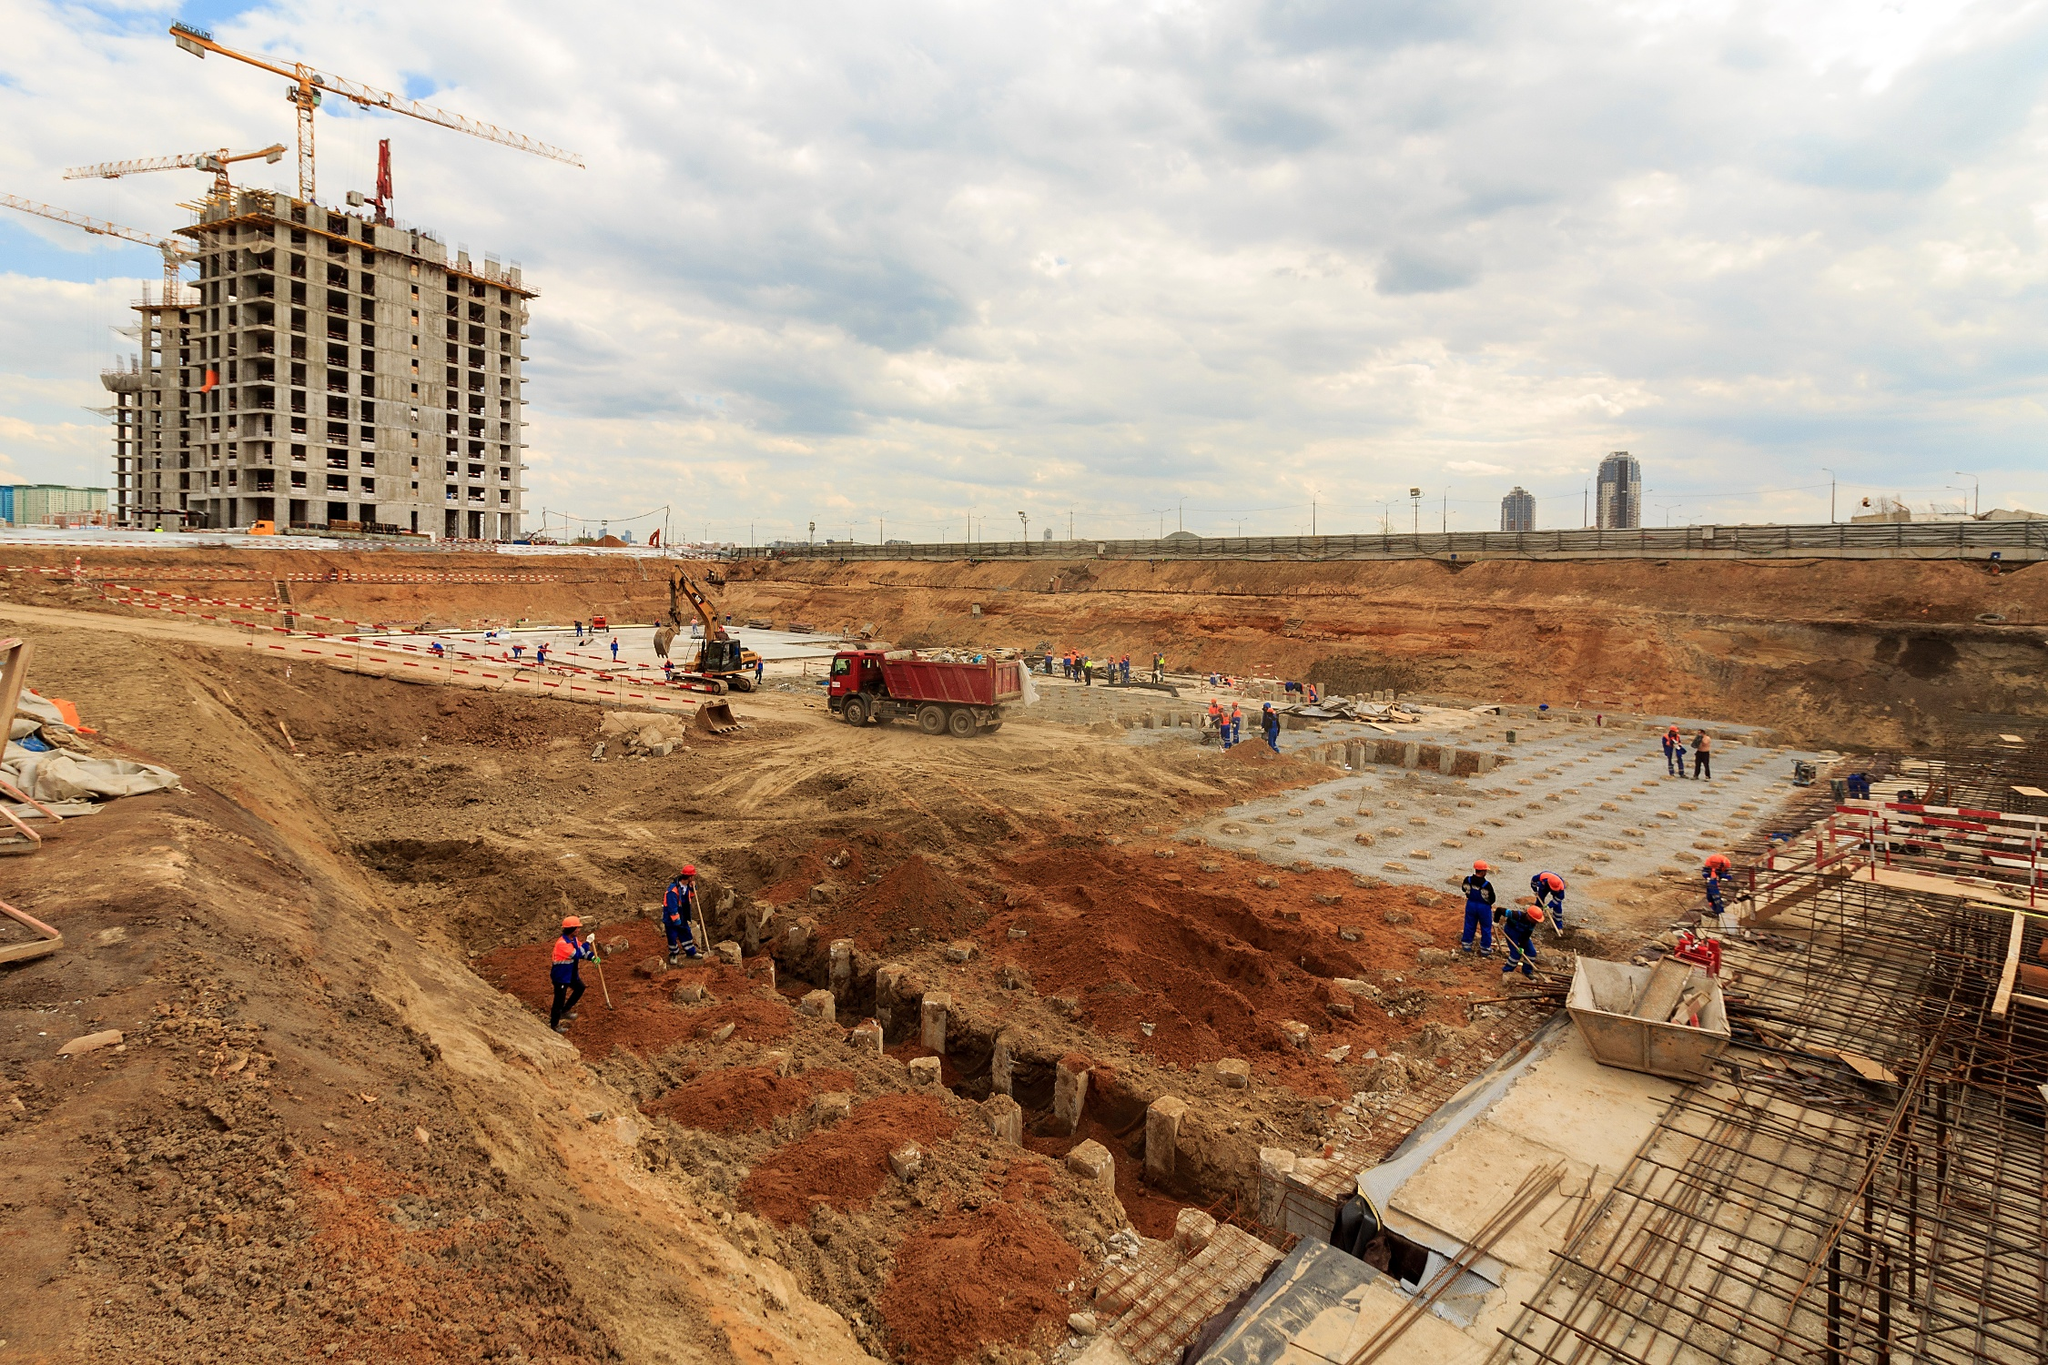If you were to imagine a story unfolding at this construction site, what would it be? Imagine a young engineer, Alex, fresh out of university, stepping onto this bustling construction site for the first time. Alex is part of a team tasked with the complex job of overseeing the foundation's stability. Despite the cloudy sky suggesting possible rain, Alex is determined to ensure everything runs smoothly. As the weeks pass, Alex calmly navigates unexpected challenges such as equipment malfunctions and late supply deliveries. Through perseverance and collaboration, Alex and the team lay a solid foundation, paving the way for a skyscraper destined to redefine the city's skyline. 